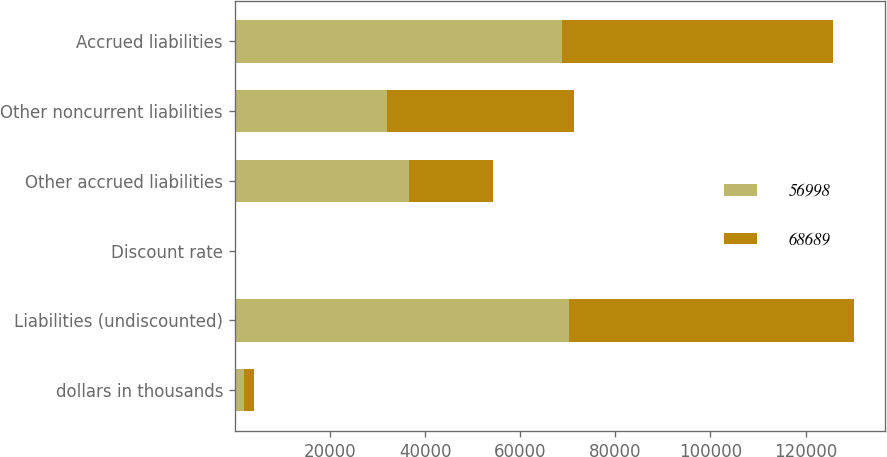<chart> <loc_0><loc_0><loc_500><loc_500><stacked_bar_chart><ecel><fcel>dollars in thousands<fcel>Liabilities (undiscounted)<fcel>Discount rate<fcel>Other accrued liabilities<fcel>Other noncurrent liabilities<fcel>Accrued liabilities<nl><fcel>56998<fcel>2010<fcel>70174<fcel>1.01<fcel>36699<fcel>31990<fcel>68689<nl><fcel>68689<fcel>2009<fcel>60072<fcel>1.77<fcel>17610<fcel>39388<fcel>56998<nl></chart> 